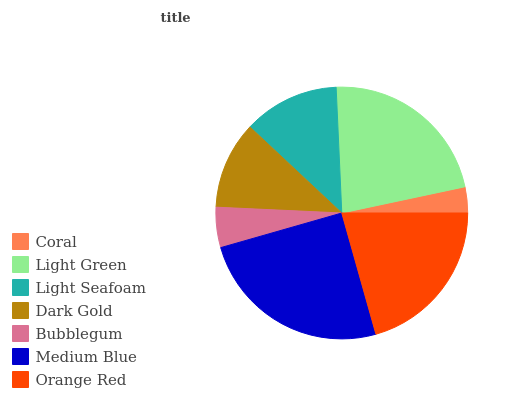Is Coral the minimum?
Answer yes or no. Yes. Is Medium Blue the maximum?
Answer yes or no. Yes. Is Light Green the minimum?
Answer yes or no. No. Is Light Green the maximum?
Answer yes or no. No. Is Light Green greater than Coral?
Answer yes or no. Yes. Is Coral less than Light Green?
Answer yes or no. Yes. Is Coral greater than Light Green?
Answer yes or no. No. Is Light Green less than Coral?
Answer yes or no. No. Is Light Seafoam the high median?
Answer yes or no. Yes. Is Light Seafoam the low median?
Answer yes or no. Yes. Is Orange Red the high median?
Answer yes or no. No. Is Orange Red the low median?
Answer yes or no. No. 